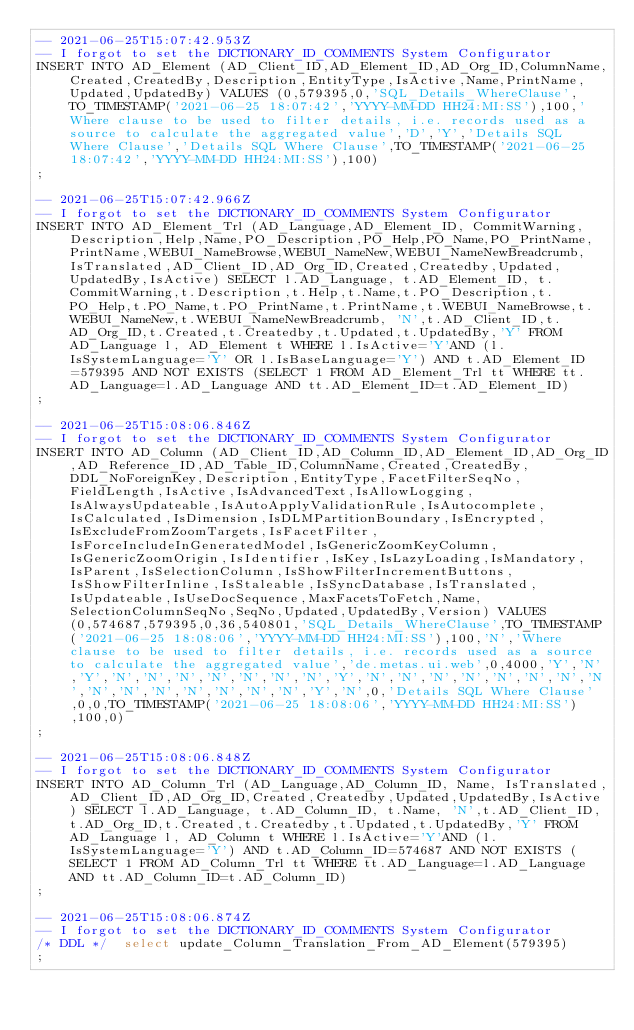<code> <loc_0><loc_0><loc_500><loc_500><_SQL_>-- 2021-06-25T15:07:42.953Z
-- I forgot to set the DICTIONARY_ID_COMMENTS System Configurator
INSERT INTO AD_Element (AD_Client_ID,AD_Element_ID,AD_Org_ID,ColumnName,Created,CreatedBy,Description,EntityType,IsActive,Name,PrintName,Updated,UpdatedBy) VALUES (0,579395,0,'SQL_Details_WhereClause',TO_TIMESTAMP('2021-06-25 18:07:42','YYYY-MM-DD HH24:MI:SS'),100,'Where clause to be used to filter details, i.e. records used as a source to calculate the aggregated value','D','Y','Details SQL Where Clause','Details SQL Where Clause',TO_TIMESTAMP('2021-06-25 18:07:42','YYYY-MM-DD HH24:MI:SS'),100)
;

-- 2021-06-25T15:07:42.966Z
-- I forgot to set the DICTIONARY_ID_COMMENTS System Configurator
INSERT INTO AD_Element_Trl (AD_Language,AD_Element_ID, CommitWarning,Description,Help,Name,PO_Description,PO_Help,PO_Name,PO_PrintName,PrintName,WEBUI_NameBrowse,WEBUI_NameNew,WEBUI_NameNewBreadcrumb, IsTranslated,AD_Client_ID,AD_Org_ID,Created,Createdby,Updated,UpdatedBy,IsActive) SELECT l.AD_Language, t.AD_Element_ID, t.CommitWarning,t.Description,t.Help,t.Name,t.PO_Description,t.PO_Help,t.PO_Name,t.PO_PrintName,t.PrintName,t.WEBUI_NameBrowse,t.WEBUI_NameNew,t.WEBUI_NameNewBreadcrumb, 'N',t.AD_Client_ID,t.AD_Org_ID,t.Created,t.Createdby,t.Updated,t.UpdatedBy,'Y' FROM AD_Language l, AD_Element t WHERE l.IsActive='Y'AND (l.IsSystemLanguage='Y' OR l.IsBaseLanguage='Y') AND t.AD_Element_ID=579395 AND NOT EXISTS (SELECT 1 FROM AD_Element_Trl tt WHERE tt.AD_Language=l.AD_Language AND tt.AD_Element_ID=t.AD_Element_ID)
;

-- 2021-06-25T15:08:06.846Z
-- I forgot to set the DICTIONARY_ID_COMMENTS System Configurator
INSERT INTO AD_Column (AD_Client_ID,AD_Column_ID,AD_Element_ID,AD_Org_ID,AD_Reference_ID,AD_Table_ID,ColumnName,Created,CreatedBy,DDL_NoForeignKey,Description,EntityType,FacetFilterSeqNo,FieldLength,IsActive,IsAdvancedText,IsAllowLogging,IsAlwaysUpdateable,IsAutoApplyValidationRule,IsAutocomplete,IsCalculated,IsDimension,IsDLMPartitionBoundary,IsEncrypted,IsExcludeFromZoomTargets,IsFacetFilter,IsForceIncludeInGeneratedModel,IsGenericZoomKeyColumn,IsGenericZoomOrigin,IsIdentifier,IsKey,IsLazyLoading,IsMandatory,IsParent,IsSelectionColumn,IsShowFilterIncrementButtons,IsShowFilterInline,IsStaleable,IsSyncDatabase,IsTranslated,IsUpdateable,IsUseDocSequence,MaxFacetsToFetch,Name,SelectionColumnSeqNo,SeqNo,Updated,UpdatedBy,Version) VALUES (0,574687,579395,0,36,540801,'SQL_Details_WhereClause',TO_TIMESTAMP('2021-06-25 18:08:06','YYYY-MM-DD HH24:MI:SS'),100,'N','Where clause to be used to filter details, i.e. records used as a source to calculate the aggregated value','de.metas.ui.web',0,4000,'Y','N','Y','N','N','N','N','N','N','N','Y','N','N','N','N','N','N','N','N','N','N','N','N','N','N','N','Y','N',0,'Details SQL Where Clause',0,0,TO_TIMESTAMP('2021-06-25 18:08:06','YYYY-MM-DD HH24:MI:SS'),100,0)
;

-- 2021-06-25T15:08:06.848Z
-- I forgot to set the DICTIONARY_ID_COMMENTS System Configurator
INSERT INTO AD_Column_Trl (AD_Language,AD_Column_ID, Name, IsTranslated,AD_Client_ID,AD_Org_ID,Created,Createdby,Updated,UpdatedBy,IsActive) SELECT l.AD_Language, t.AD_Column_ID, t.Name, 'N',t.AD_Client_ID,t.AD_Org_ID,t.Created,t.Createdby,t.Updated,t.UpdatedBy,'Y' FROM AD_Language l, AD_Column t WHERE l.IsActive='Y'AND (l.IsSystemLanguage='Y') AND t.AD_Column_ID=574687 AND NOT EXISTS (SELECT 1 FROM AD_Column_Trl tt WHERE tt.AD_Language=l.AD_Language AND tt.AD_Column_ID=t.AD_Column_ID)
;

-- 2021-06-25T15:08:06.874Z
-- I forgot to set the DICTIONARY_ID_COMMENTS System Configurator
/* DDL */  select update_Column_Translation_From_AD_Element(579395) 
;
</code> 